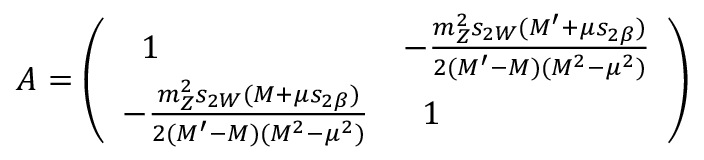Convert formula to latex. <formula><loc_0><loc_0><loc_500><loc_500>A = \left ( \begin{array} { l l } { \, 1 } & { { - \frac { m _ { Z } ^ { 2 } s _ { 2 W } ( M ^ { \prime } + \mu s _ { 2 \beta } ) } { 2 ( M ^ { \prime } - M ) ( M ^ { 2 } - \mu ^ { 2 } ) } } } \\ { { - \frac { m _ { Z } ^ { 2 } s _ { 2 W } ( M + \mu s _ { 2 \beta } ) } { 2 ( M ^ { \prime } - M ) ( M ^ { 2 } - \mu ^ { 2 } ) } } } & { \, 1 } \end{array} \right )</formula> 